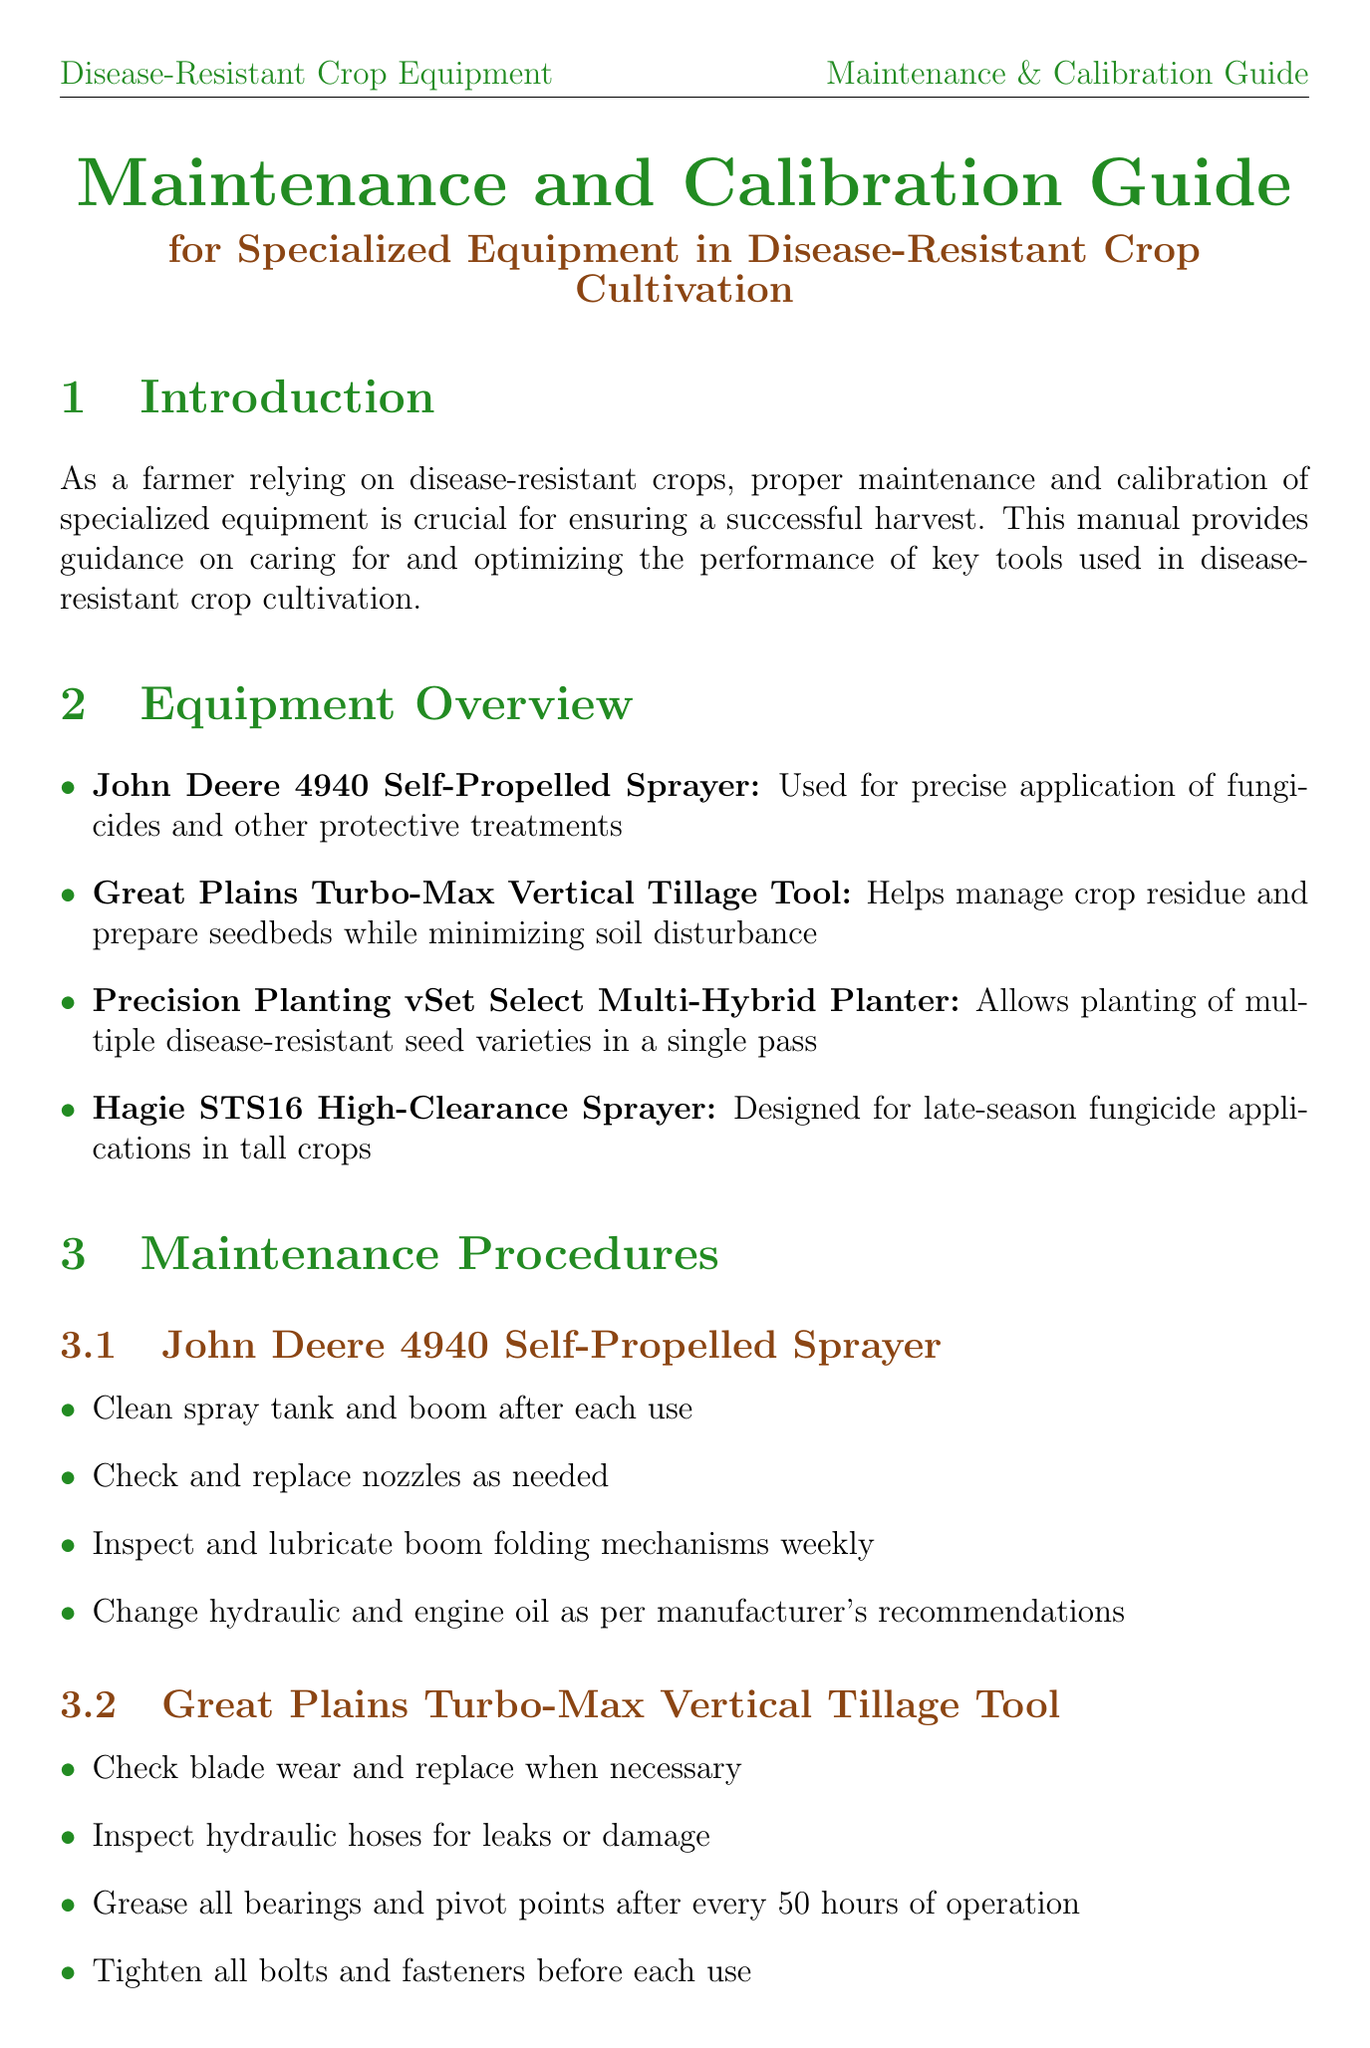What is the title of the manual? The title of the manual is mentioned at the beginning of the document.
Answer: Maintenance and Calibration Guide for Specialized Equipment in Disease-Resistant Crop Cultivation Which equipment is used for precise application of fungicides? The document lists the equipment along with their descriptions, identifying which is used for specific tasks.
Answer: John Deere 4940 Self-Propelled Sprayer How often should the boom folding mechanisms be lubricated for the John Deere sprayer? The document specifies maintenance procedures for each piece of equipment, including how often certain tasks should be performed.
Answer: Weekly What should be checked for leaks in the Great Plains Turbo-Max tool? The maintenance procedures elaborate the checks required for each equipment.
Answer: Hydraulic hoses What is one solution to fix an uneven spray pattern? The troubleshooting section provides potential solutions for common issues that arise during equipment use.
Answer: Check for clogged nozzles What should be calibrated annually for the Precision Planting planter? Calibration procedures outline specific components that need regular calibration to maintain effectiveness.
Answer: Seed sensors What type of nozzles should be used to reduce drift during spraying? The FAQ provides solutions for issues related to equipment usage.
Answer: Drift reduction nozzles What is the importance of maintaining accurate records? The record-keeping section emphasizes the significance of tracking various operational specifics.
Answer: Crucial for tracking equipment performance, maintenance schedules, and calibration history 